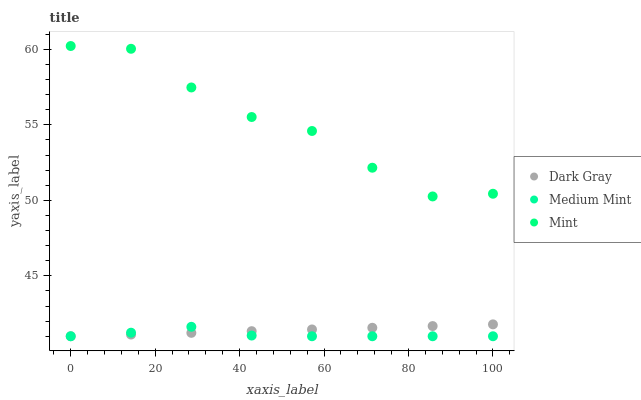Does Medium Mint have the minimum area under the curve?
Answer yes or no. Yes. Does Mint have the maximum area under the curve?
Answer yes or no. Yes. Does Mint have the minimum area under the curve?
Answer yes or no. No. Does Medium Mint have the maximum area under the curve?
Answer yes or no. No. Is Dark Gray the smoothest?
Answer yes or no. Yes. Is Mint the roughest?
Answer yes or no. Yes. Is Medium Mint the smoothest?
Answer yes or no. No. Is Medium Mint the roughest?
Answer yes or no. No. Does Dark Gray have the lowest value?
Answer yes or no. Yes. Does Mint have the lowest value?
Answer yes or no. No. Does Mint have the highest value?
Answer yes or no. Yes. Does Medium Mint have the highest value?
Answer yes or no. No. Is Medium Mint less than Mint?
Answer yes or no. Yes. Is Mint greater than Medium Mint?
Answer yes or no. Yes. Does Dark Gray intersect Medium Mint?
Answer yes or no. Yes. Is Dark Gray less than Medium Mint?
Answer yes or no. No. Is Dark Gray greater than Medium Mint?
Answer yes or no. No. Does Medium Mint intersect Mint?
Answer yes or no. No. 